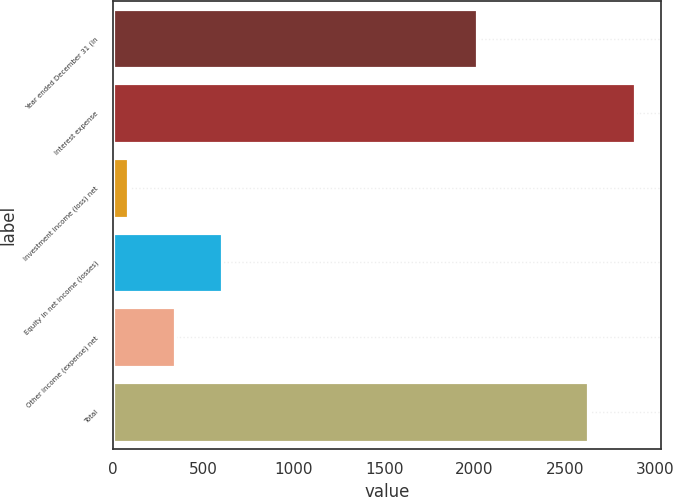Convert chart to OTSL. <chart><loc_0><loc_0><loc_500><loc_500><bar_chart><fcel>Year ended December 31 (in<fcel>Interest expense<fcel>Investment income (loss) net<fcel>Equity in net income (losses)<fcel>Other income (expense) net<fcel>Total<nl><fcel>2015<fcel>2888.1<fcel>81<fcel>605.2<fcel>343.1<fcel>2626<nl></chart> 